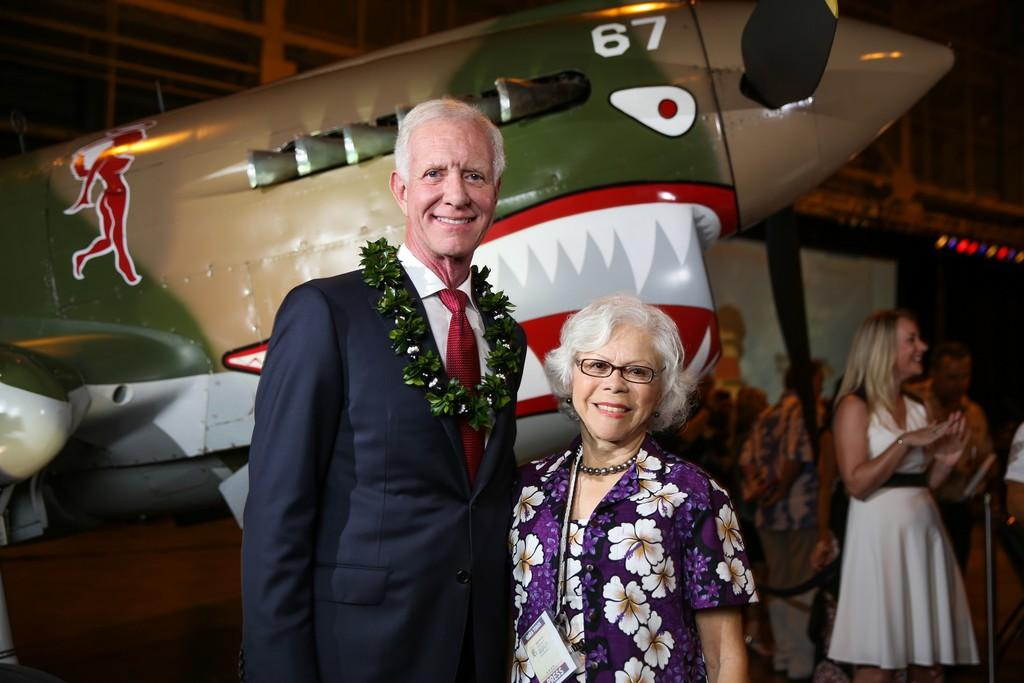How many people are visible in the image? There are two persons standing and smiling in the image. Where are the other people located in the image? There are people standing on the right side of the image. What can be seen in the background of the image? The background of the image is blurry. What is the main subject of the image? The main subject of the image is an aircraft. What type of curve can be seen in the caption of the image? There is no caption present in the image, so it is not possible to determine if there is a curve or not. 